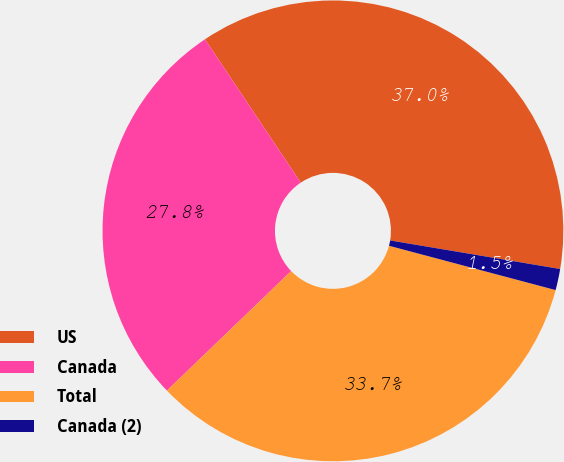Convert chart to OTSL. <chart><loc_0><loc_0><loc_500><loc_500><pie_chart><fcel>US<fcel>Canada<fcel>Total<fcel>Canada (2)<nl><fcel>37.02%<fcel>27.82%<fcel>33.67%<fcel>1.49%<nl></chart> 